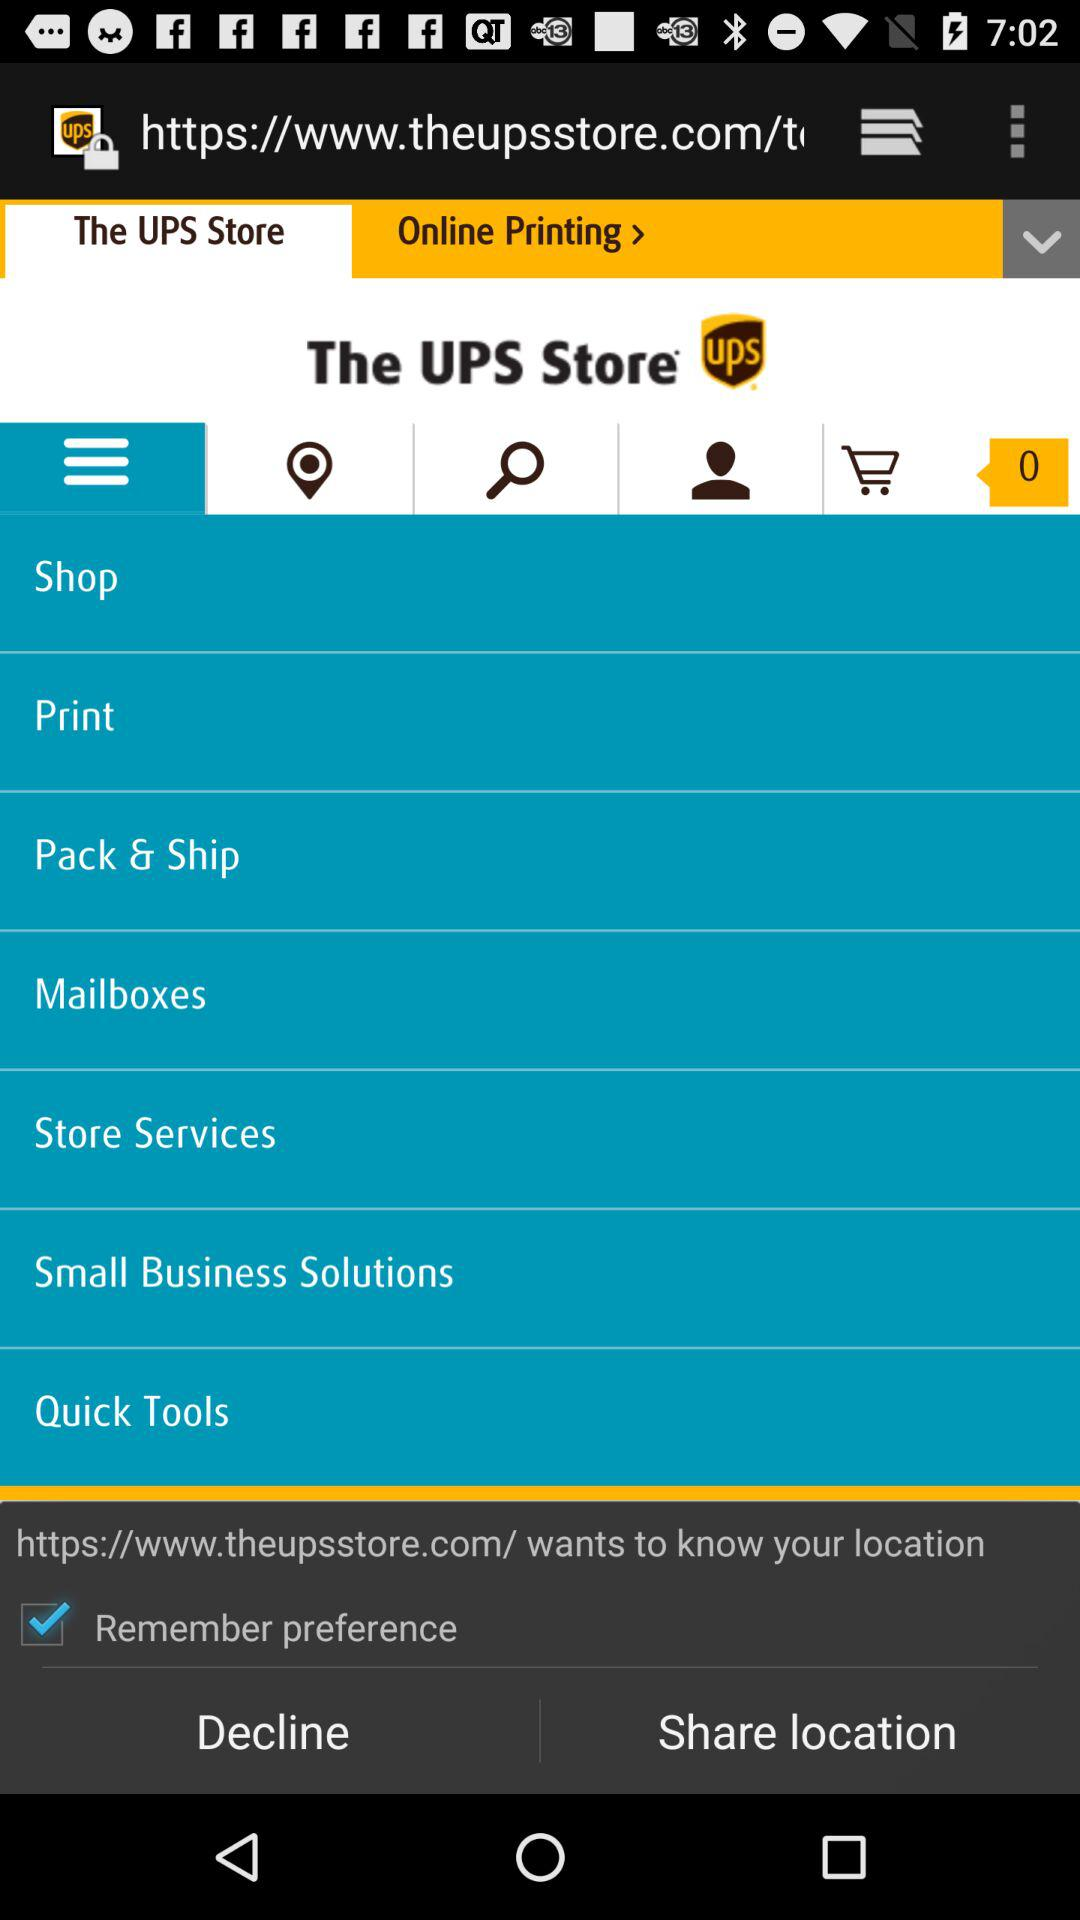What is the location of The UPS Store?
When the provided information is insufficient, respond with <no answer>. <no answer> 